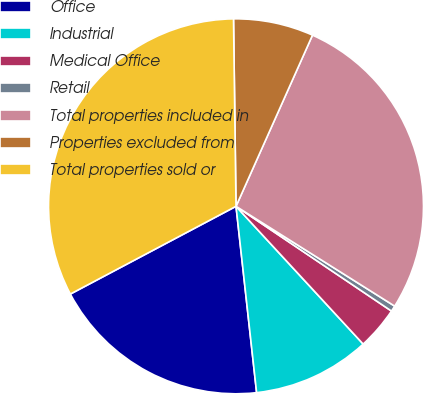Convert chart. <chart><loc_0><loc_0><loc_500><loc_500><pie_chart><fcel>Office<fcel>Industrial<fcel>Medical Office<fcel>Retail<fcel>Total properties included in<fcel>Properties excluded from<fcel>Total properties sold or<nl><fcel>19.0%<fcel>10.11%<fcel>3.7%<fcel>0.5%<fcel>27.25%<fcel>6.9%<fcel>32.54%<nl></chart> 